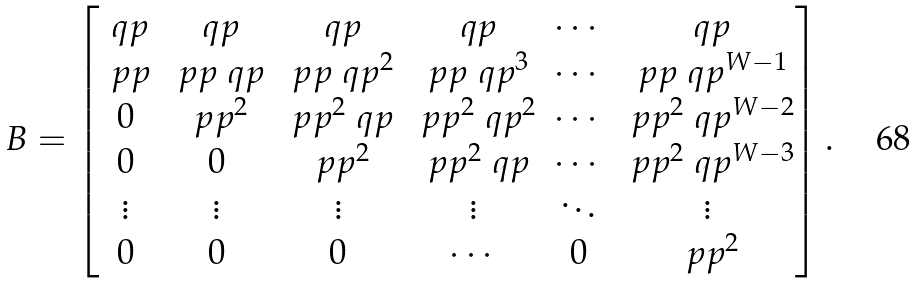Convert formula to latex. <formula><loc_0><loc_0><loc_500><loc_500>B = \begin{bmatrix} \ q p & \ q p & \ q p & \ q p & \cdots & \ q p \\ \ p p & \ p p \ q p & \ p p \ q p ^ { 2 } & \ p p \ q p ^ { 3 } & \cdots & \ p p \ q p ^ { W - 1 } \\ 0 & \ p p ^ { 2 } & \ p p ^ { 2 } \ q p & \ p p ^ { 2 } \ q p ^ { 2 } & \cdots & \ p p ^ { 2 } \ q p ^ { W - 2 } \\ 0 & 0 & \ p p ^ { 2 } & \ p p ^ { 2 } \ q p & \cdots & \ p p ^ { 2 } \ q p ^ { W - 3 } \\ \vdots & \vdots & \vdots & \vdots & \ddots & \vdots \\ 0 & 0 & 0 & \cdots & 0 & \ p p ^ { 2 } \end{bmatrix} .</formula> 